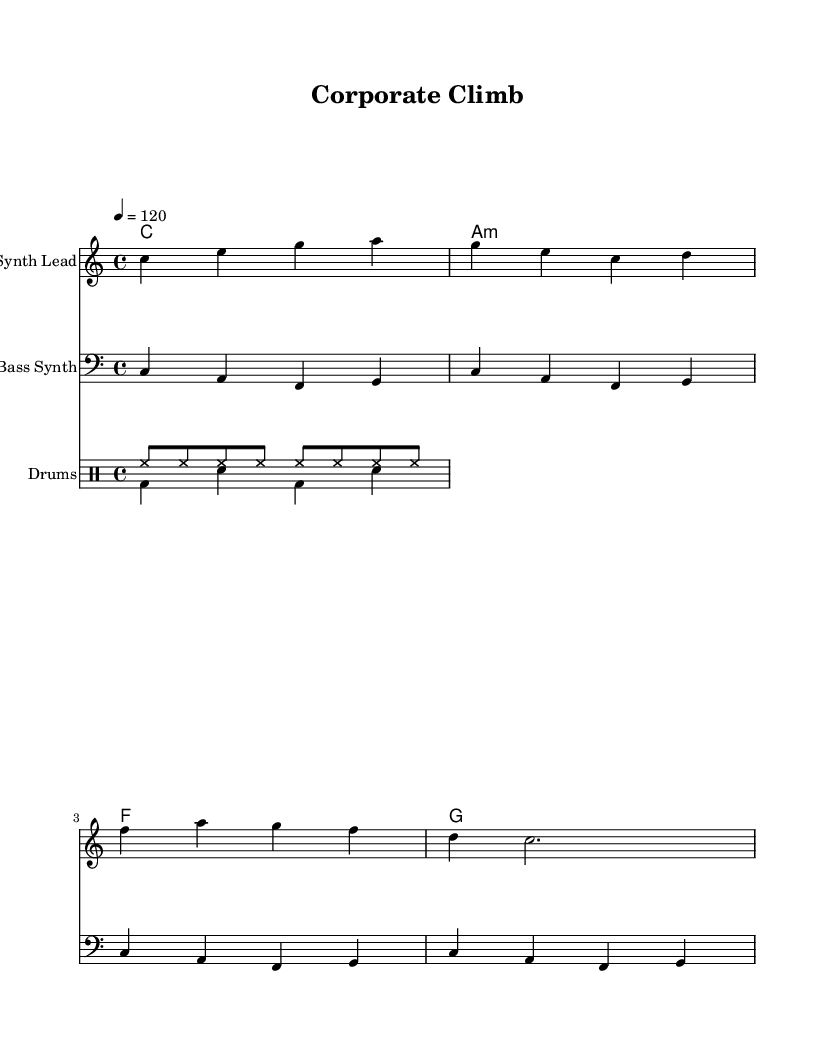What is the key signature of this music? The key signature is C major, which has no sharps or flats.
Answer: C major What is the time signature? The time signature is 4/4, indicating that there are four beats in each measure.
Answer: 4/4 What is the tempo marking in this music? The tempo marking indicates the rate at which the piece should be played, set at 120 beats per minute.
Answer: 120 What type of instrument is indicated for the melody? The melody is indicated to be played on a "Synth Lead", suggesting a synthetic sound characteristic of electronic music.
Answer: Synth Lead How many measures are contained in the melody? The melody consists of four measures, each indicated by the vertical lines separating the rhythmic patterns.
Answer: 4 What is the relationship between the bass line and the melody? The bass line provides harmonic support and rhythmic foundation that complements the melody, typical in electronic music to create depth.
Answer: Complementary What rhythmic elements are present in the drum patterns? The drum patterns include a steady hi-hat pattern along with bass and snare hits, which creates the driving beat essential in electronic dance music.
Answer: Steady hi-hat with bass and snare 